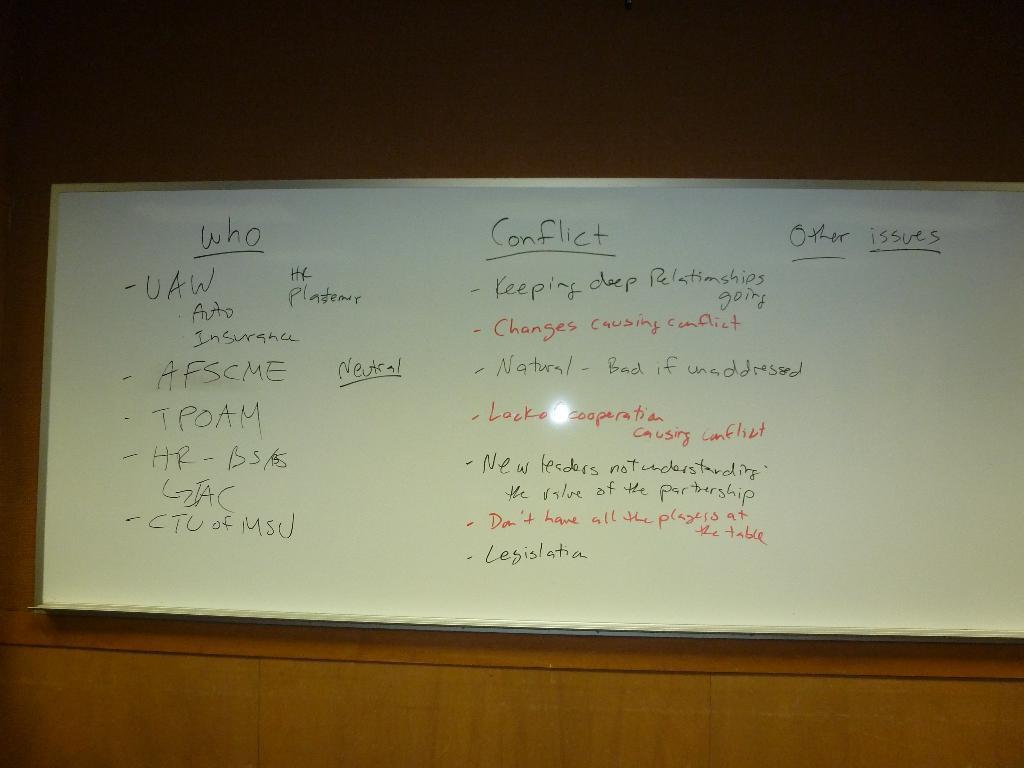How would you summarize this image in a sentence or two? In this image I can see a board on the wall. This image is taken may be in a room. 